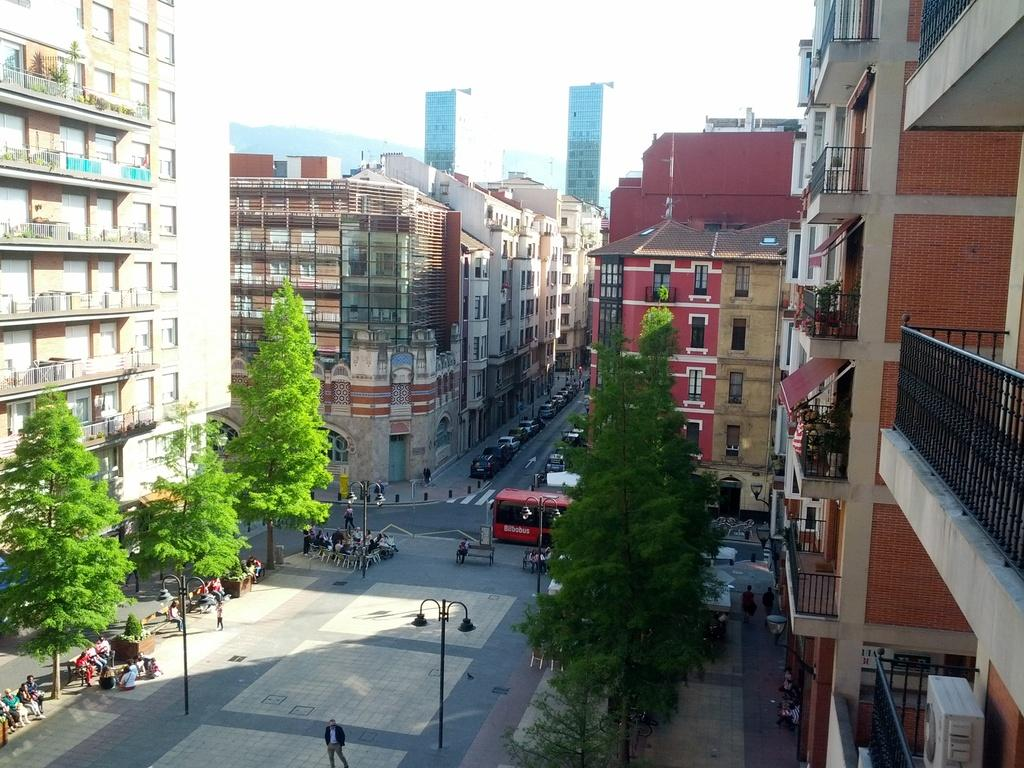What can be seen on the road in the image? There are vehicles on the road in the image. Who or what is present in the group in the image? There is a group of people in the image. What objects are present in the image that are used for supporting or holding up other objects? There are poles in the image. What objects in the image provide illumination? There are lights in the image. What type of structures can be seen in the image? There are buildings in the image. What type of vegetation can be seen in the image? There are trees in the image. What part of the natural environment is visible in the background of the image? The sky is visible in the background of the image. How many eggs are being carried by the carpenter in the image? There is no carpenter or eggs present in the image. What type of apples are being harvested by the group of people in the image? There are no apples or harvesting activities depicted in the image. 